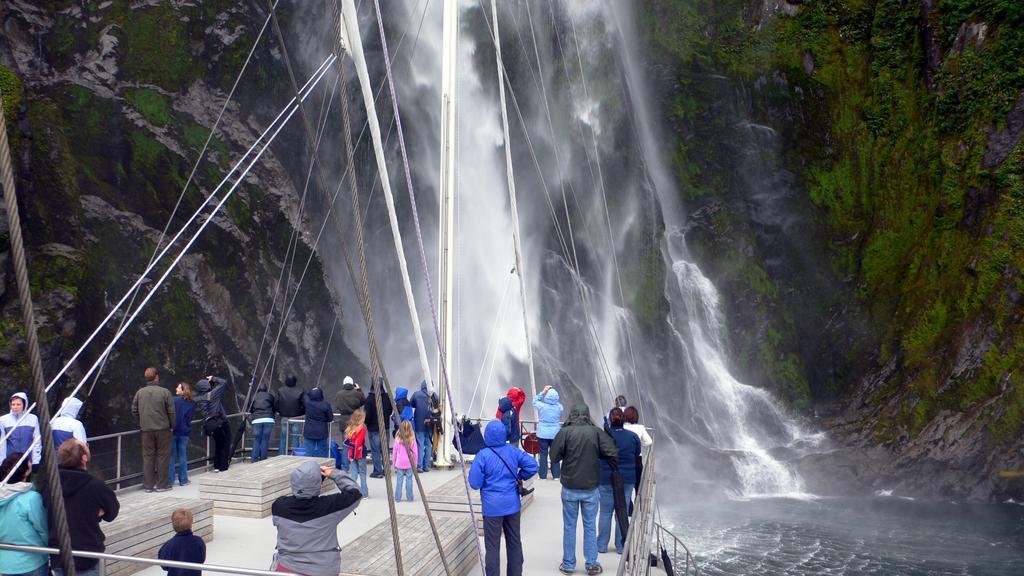In one or two sentences, can you explain what this image depicts? In this picture I can see few people standing on the boat. I can see water flowing. 